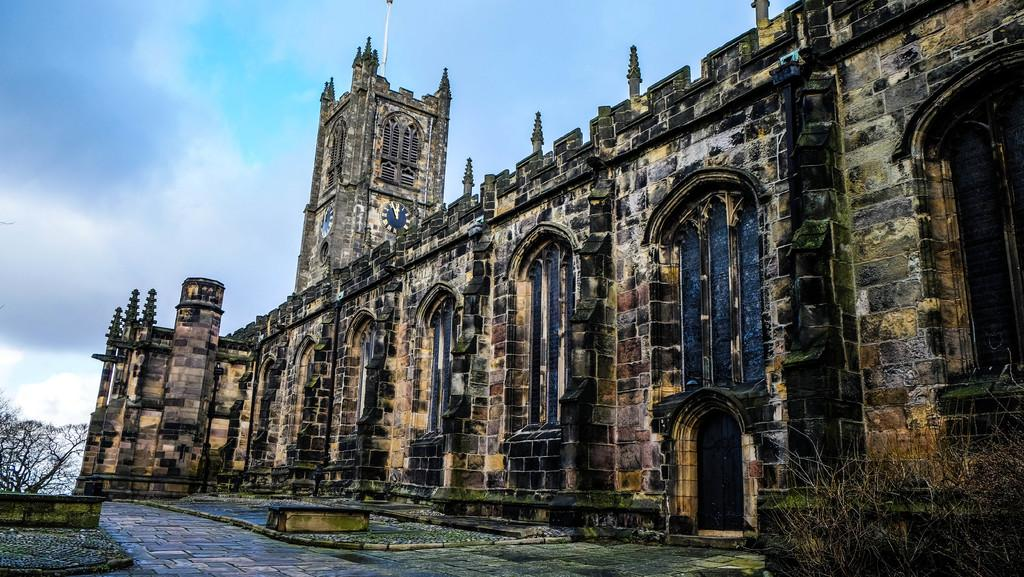What type of structure is visible in the image? There is a building in the image. What else can be seen in the image besides the building? There are plants, clocks, a pole, and other objects in the image. How would you describe the sky in the image? The sky is cloudy in the image. Are there any dolls in the image? No, there are no dolls present in the image. What is the fifth object in the image? There is no specific mention of a fifth object in the provided facts, so it is not possible to answer that question. 